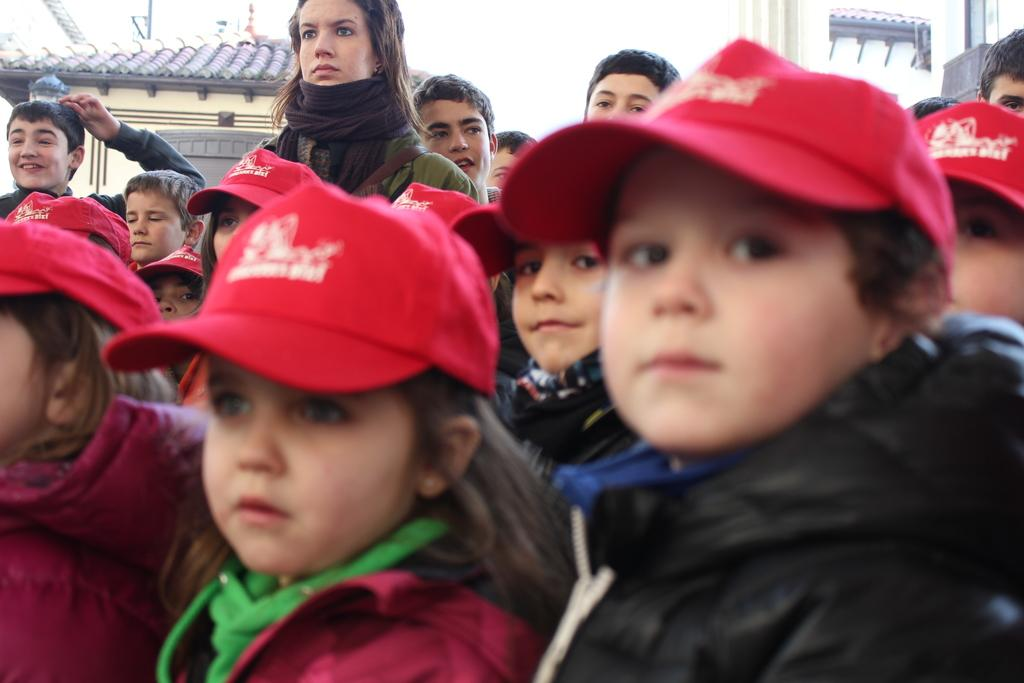What is happening in the image? There is a group of people standing in the image. Can you describe the attire of some people in the group? Some people in the group are wearing hats. What can be seen in the distance behind the group? There are houses in the background of the image. What type of doll is being crushed by the heat in the image? There is no doll or heat present in the image; it features a group of people standing with some wearing hats, and houses in the background. 